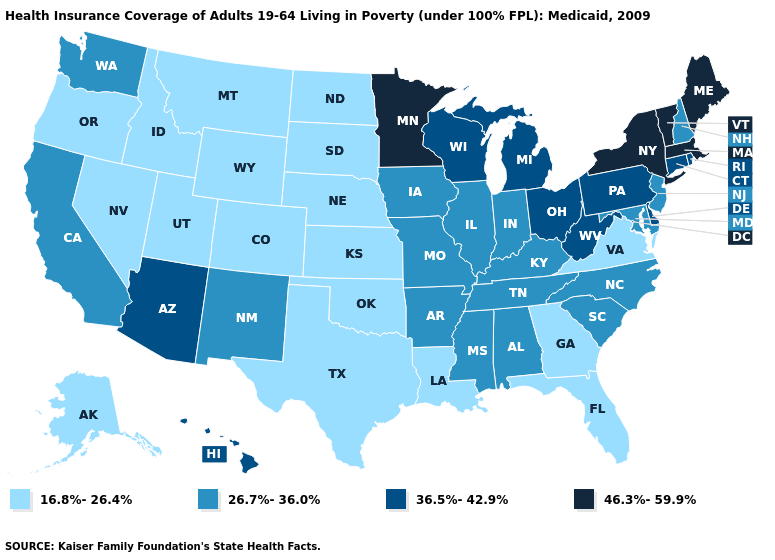Does Rhode Island have the highest value in the Northeast?
Give a very brief answer. No. What is the lowest value in the USA?
Concise answer only. 16.8%-26.4%. Name the states that have a value in the range 26.7%-36.0%?
Write a very short answer. Alabama, Arkansas, California, Illinois, Indiana, Iowa, Kentucky, Maryland, Mississippi, Missouri, New Hampshire, New Jersey, New Mexico, North Carolina, South Carolina, Tennessee, Washington. Which states have the lowest value in the MidWest?
Short answer required. Kansas, Nebraska, North Dakota, South Dakota. Name the states that have a value in the range 26.7%-36.0%?
Short answer required. Alabama, Arkansas, California, Illinois, Indiana, Iowa, Kentucky, Maryland, Mississippi, Missouri, New Hampshire, New Jersey, New Mexico, North Carolina, South Carolina, Tennessee, Washington. What is the value of Utah?
Keep it brief. 16.8%-26.4%. What is the highest value in the Northeast ?
Quick response, please. 46.3%-59.9%. What is the lowest value in the USA?
Answer briefly. 16.8%-26.4%. What is the value of Illinois?
Concise answer only. 26.7%-36.0%. What is the value of Nebraska?
Concise answer only. 16.8%-26.4%. Name the states that have a value in the range 36.5%-42.9%?
Quick response, please. Arizona, Connecticut, Delaware, Hawaii, Michigan, Ohio, Pennsylvania, Rhode Island, West Virginia, Wisconsin. Which states have the lowest value in the Northeast?
Keep it brief. New Hampshire, New Jersey. Among the states that border New Mexico , which have the lowest value?
Concise answer only. Colorado, Oklahoma, Texas, Utah. 